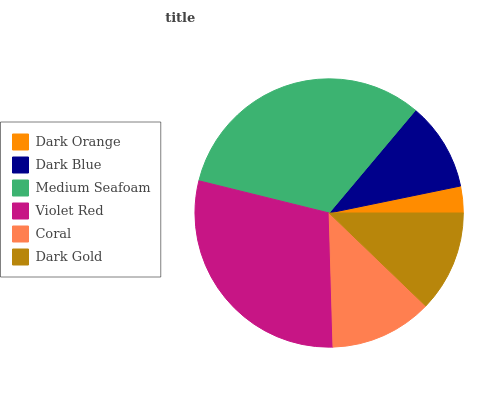Is Dark Orange the minimum?
Answer yes or no. Yes. Is Medium Seafoam the maximum?
Answer yes or no. Yes. Is Dark Blue the minimum?
Answer yes or no. No. Is Dark Blue the maximum?
Answer yes or no. No. Is Dark Blue greater than Dark Orange?
Answer yes or no. Yes. Is Dark Orange less than Dark Blue?
Answer yes or no. Yes. Is Dark Orange greater than Dark Blue?
Answer yes or no. No. Is Dark Blue less than Dark Orange?
Answer yes or no. No. Is Coral the high median?
Answer yes or no. Yes. Is Dark Gold the low median?
Answer yes or no. Yes. Is Violet Red the high median?
Answer yes or no. No. Is Coral the low median?
Answer yes or no. No. 